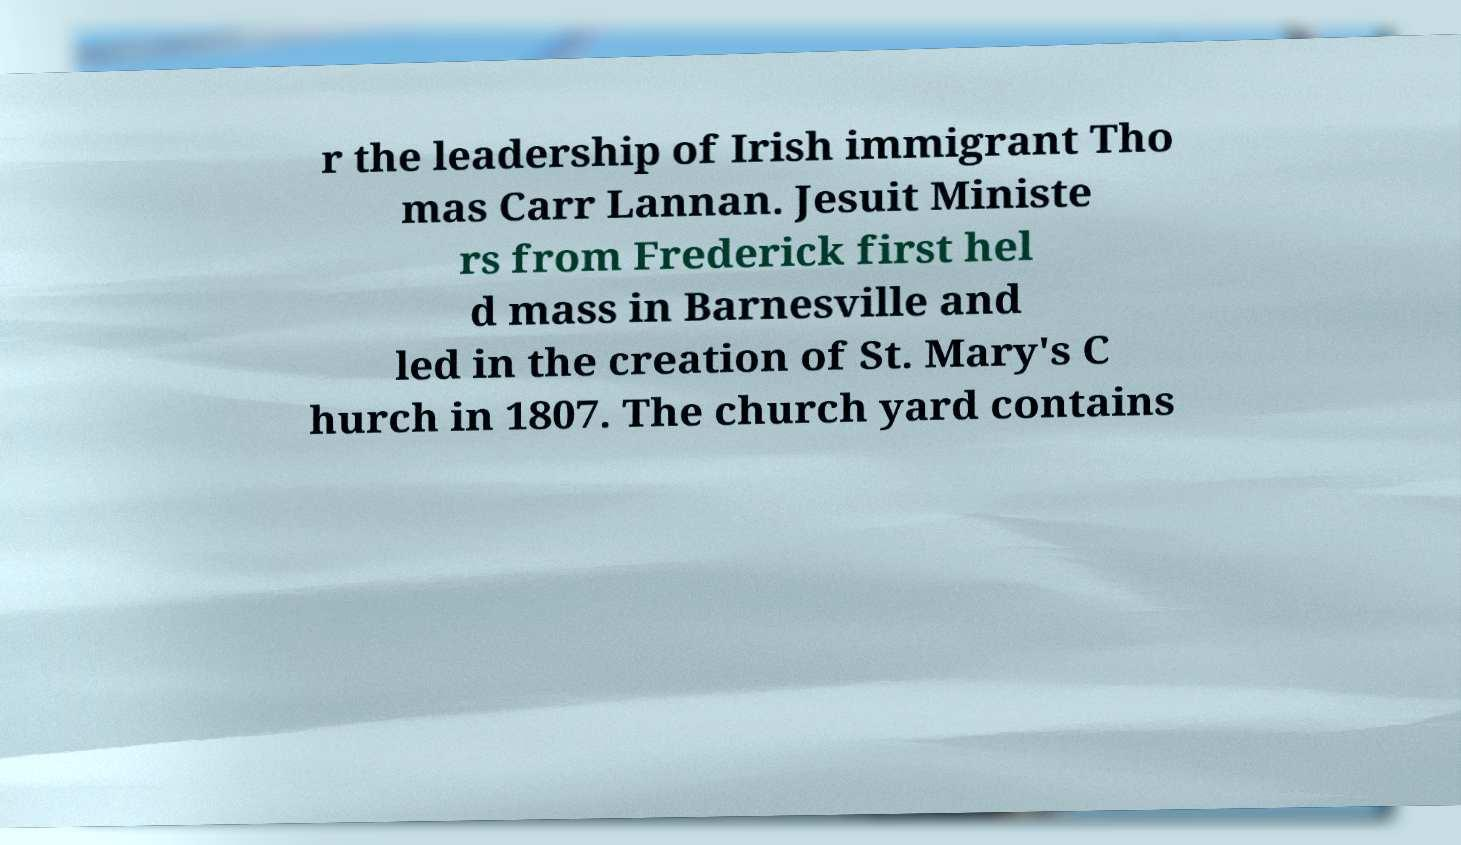There's text embedded in this image that I need extracted. Can you transcribe it verbatim? r the leadership of Irish immigrant Tho mas Carr Lannan. Jesuit Ministe rs from Frederick first hel d mass in Barnesville and led in the creation of St. Mary's C hurch in 1807. The church yard contains 